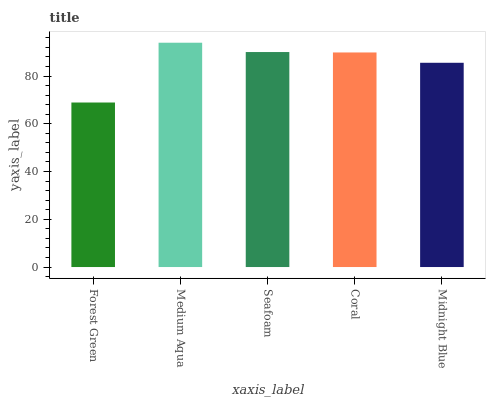Is Seafoam the minimum?
Answer yes or no. No. Is Seafoam the maximum?
Answer yes or no. No. Is Medium Aqua greater than Seafoam?
Answer yes or no. Yes. Is Seafoam less than Medium Aqua?
Answer yes or no. Yes. Is Seafoam greater than Medium Aqua?
Answer yes or no. No. Is Medium Aqua less than Seafoam?
Answer yes or no. No. Is Coral the high median?
Answer yes or no. Yes. Is Coral the low median?
Answer yes or no. Yes. Is Medium Aqua the high median?
Answer yes or no. No. Is Seafoam the low median?
Answer yes or no. No. 